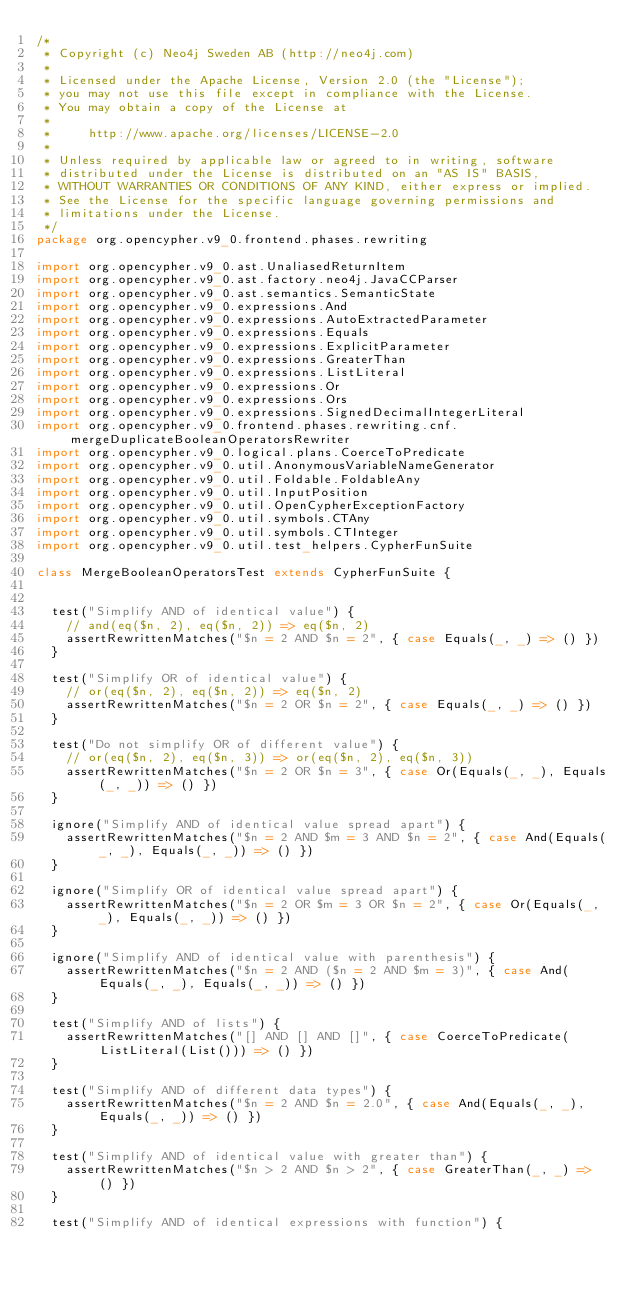Convert code to text. <code><loc_0><loc_0><loc_500><loc_500><_Scala_>/*
 * Copyright (c) Neo4j Sweden AB (http://neo4j.com)
 *
 * Licensed under the Apache License, Version 2.0 (the "License");
 * you may not use this file except in compliance with the License.
 * You may obtain a copy of the License at
 *
 *     http://www.apache.org/licenses/LICENSE-2.0
 *
 * Unless required by applicable law or agreed to in writing, software
 * distributed under the License is distributed on an "AS IS" BASIS,
 * WITHOUT WARRANTIES OR CONDITIONS OF ANY KIND, either express or implied.
 * See the License for the specific language governing permissions and
 * limitations under the License.
 */
package org.opencypher.v9_0.frontend.phases.rewriting

import org.opencypher.v9_0.ast.UnaliasedReturnItem
import org.opencypher.v9_0.ast.factory.neo4j.JavaCCParser
import org.opencypher.v9_0.ast.semantics.SemanticState
import org.opencypher.v9_0.expressions.And
import org.opencypher.v9_0.expressions.AutoExtractedParameter
import org.opencypher.v9_0.expressions.Equals
import org.opencypher.v9_0.expressions.ExplicitParameter
import org.opencypher.v9_0.expressions.GreaterThan
import org.opencypher.v9_0.expressions.ListLiteral
import org.opencypher.v9_0.expressions.Or
import org.opencypher.v9_0.expressions.Ors
import org.opencypher.v9_0.expressions.SignedDecimalIntegerLiteral
import org.opencypher.v9_0.frontend.phases.rewriting.cnf.mergeDuplicateBooleanOperatorsRewriter
import org.opencypher.v9_0.logical.plans.CoerceToPredicate
import org.opencypher.v9_0.util.AnonymousVariableNameGenerator
import org.opencypher.v9_0.util.Foldable.FoldableAny
import org.opencypher.v9_0.util.InputPosition
import org.opencypher.v9_0.util.OpenCypherExceptionFactory
import org.opencypher.v9_0.util.symbols.CTAny
import org.opencypher.v9_0.util.symbols.CTInteger
import org.opencypher.v9_0.util.test_helpers.CypherFunSuite

class MergeBooleanOperatorsTest extends CypherFunSuite {


  test("Simplify AND of identical value") {
    // and(eq($n, 2), eq($n, 2)) => eq($n, 2)
    assertRewrittenMatches("$n = 2 AND $n = 2", { case Equals(_, _) => () })
  }

  test("Simplify OR of identical value") {
    // or(eq($n, 2), eq($n, 2)) => eq($n, 2)
    assertRewrittenMatches("$n = 2 OR $n = 2", { case Equals(_, _) => () })
  }

  test("Do not simplify OR of different value") {
    // or(eq($n, 2), eq($n, 3)) => or(eq($n, 2), eq($n, 3))
    assertRewrittenMatches("$n = 2 OR $n = 3", { case Or(Equals(_, _), Equals(_, _)) => () })
  }

  ignore("Simplify AND of identical value spread apart") {
    assertRewrittenMatches("$n = 2 AND $m = 3 AND $n = 2", { case And(Equals(_, _), Equals(_, _)) => () })
  }

  ignore("Simplify OR of identical value spread apart") {
    assertRewrittenMatches("$n = 2 OR $m = 3 OR $n = 2", { case Or(Equals(_, _), Equals(_, _)) => () })
  }

  ignore("Simplify AND of identical value with parenthesis") {
    assertRewrittenMatches("$n = 2 AND ($n = 2 AND $m = 3)", { case And(Equals(_, _), Equals(_, _)) => () })
  }

  test("Simplify AND of lists") {
    assertRewrittenMatches("[] AND [] AND []", { case CoerceToPredicate(ListLiteral(List())) => () })
  }

  test("Simplify AND of different data types") {
    assertRewrittenMatches("$n = 2 AND $n = 2.0", { case And(Equals(_, _), Equals(_, _)) => () })
  }

  test("Simplify AND of identical value with greater than") {
    assertRewrittenMatches("$n > 2 AND $n > 2", { case GreaterThan(_, _) => () })
  }

  test("Simplify AND of identical expressions with function") {</code> 